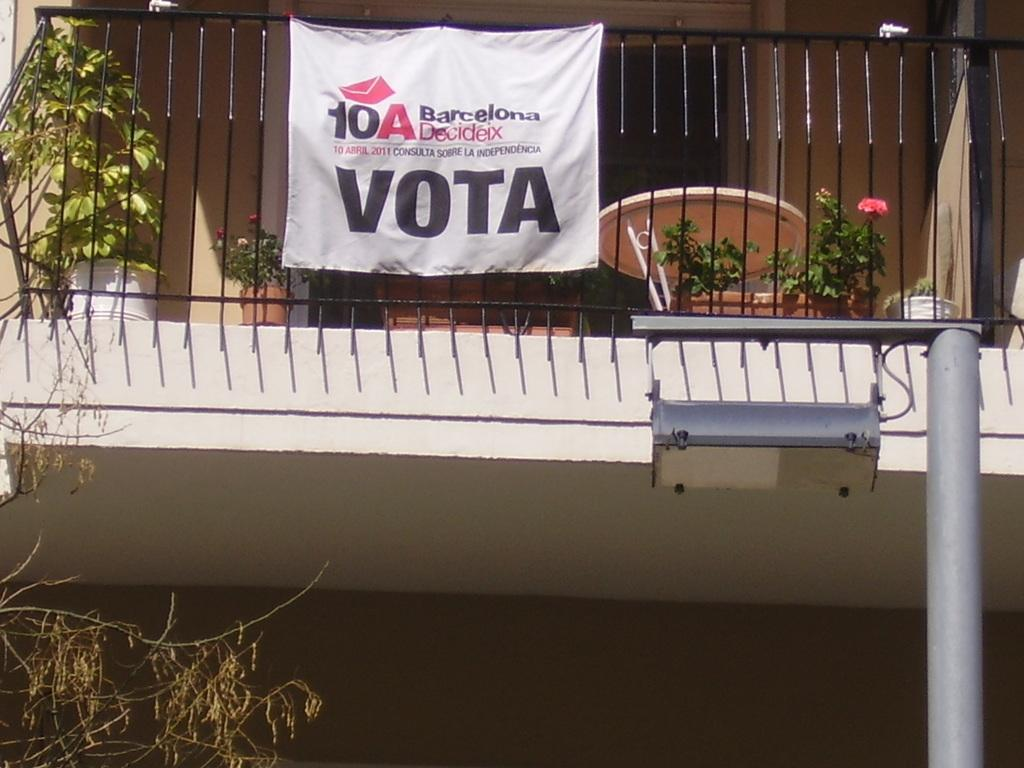What type of structure is present in the image? There is a building in the image. What can be seen near the building? There are flower pots and a railing in the image. What is the purpose of the railing? The railing is likely for safety or decoration. What other objects are visible in the image? There is a table and a light pole in the image. What is attached to the railing? A white banner is attached to the railing. What type of vessel is being used to serve drinks on the table in the image? There is no vessel or drinks present on the table in the image. What type of collar is visible on the flower pots in the image? There are no collars on the flower pots in the image; they are simply flower pots. 